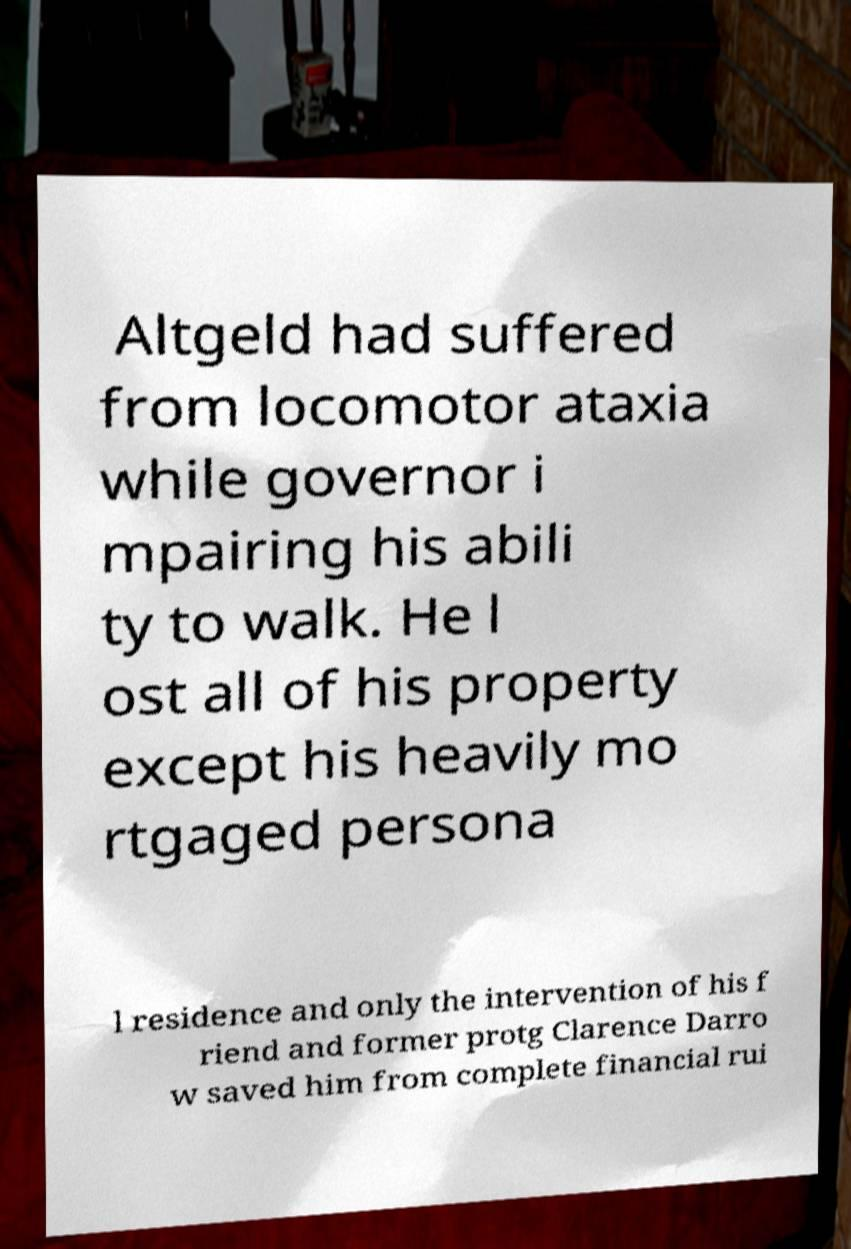There's text embedded in this image that I need extracted. Can you transcribe it verbatim? Altgeld had suffered from locomotor ataxia while governor i mpairing his abili ty to walk. He l ost all of his property except his heavily mo rtgaged persona l residence and only the intervention of his f riend and former protg Clarence Darro w saved him from complete financial rui 